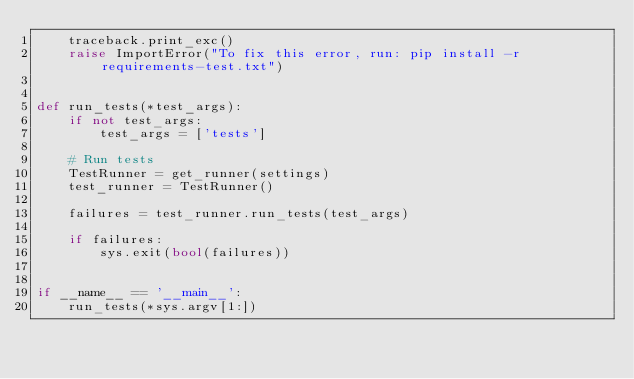<code> <loc_0><loc_0><loc_500><loc_500><_Python_>    traceback.print_exc()
    raise ImportError("To fix this error, run: pip install -r requirements-test.txt")


def run_tests(*test_args):
    if not test_args:
        test_args = ['tests']

    # Run tests
    TestRunner = get_runner(settings)
    test_runner = TestRunner()

    failures = test_runner.run_tests(test_args)

    if failures:
        sys.exit(bool(failures))


if __name__ == '__main__':
    run_tests(*sys.argv[1:])
</code> 